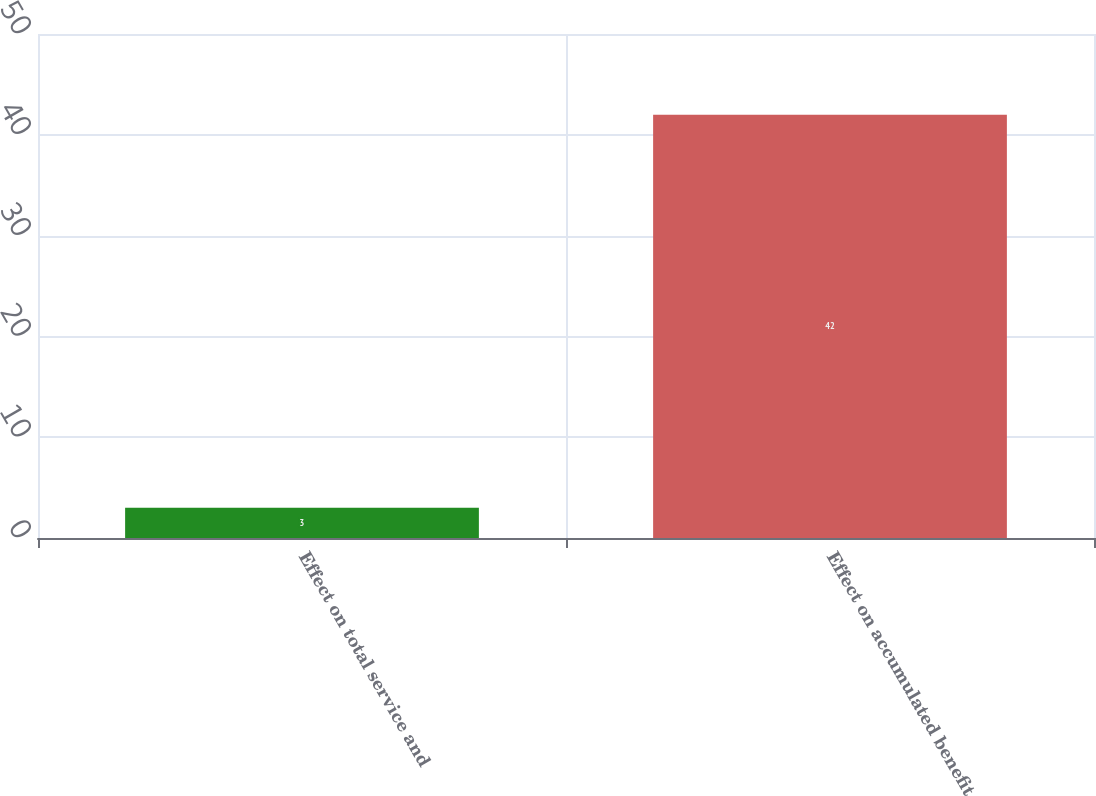<chart> <loc_0><loc_0><loc_500><loc_500><bar_chart><fcel>Effect on total service and<fcel>Effect on accumulated benefit<nl><fcel>3<fcel>42<nl></chart> 